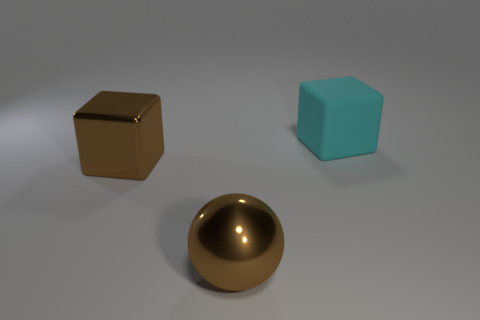Add 2 cyan matte things. How many objects exist? 5 Subtract all blocks. How many objects are left? 1 Add 3 large spheres. How many large spheres are left? 4 Add 2 gray blocks. How many gray blocks exist? 2 Subtract 0 yellow cylinders. How many objects are left? 3 Subtract all large cyan objects. Subtract all purple matte balls. How many objects are left? 2 